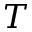<formula> <loc_0><loc_0><loc_500><loc_500>T</formula> 